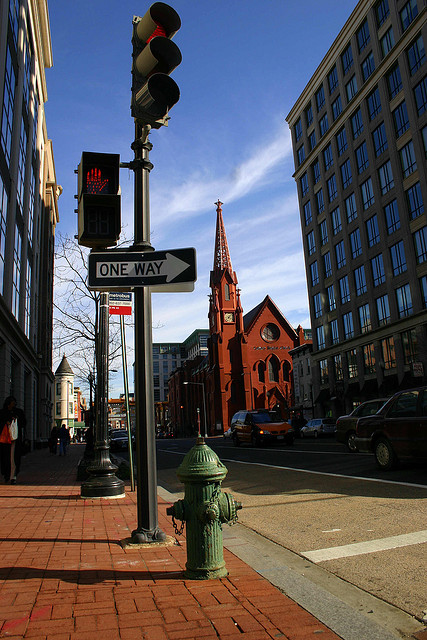Identify the text contained in this image. ONE WAY 